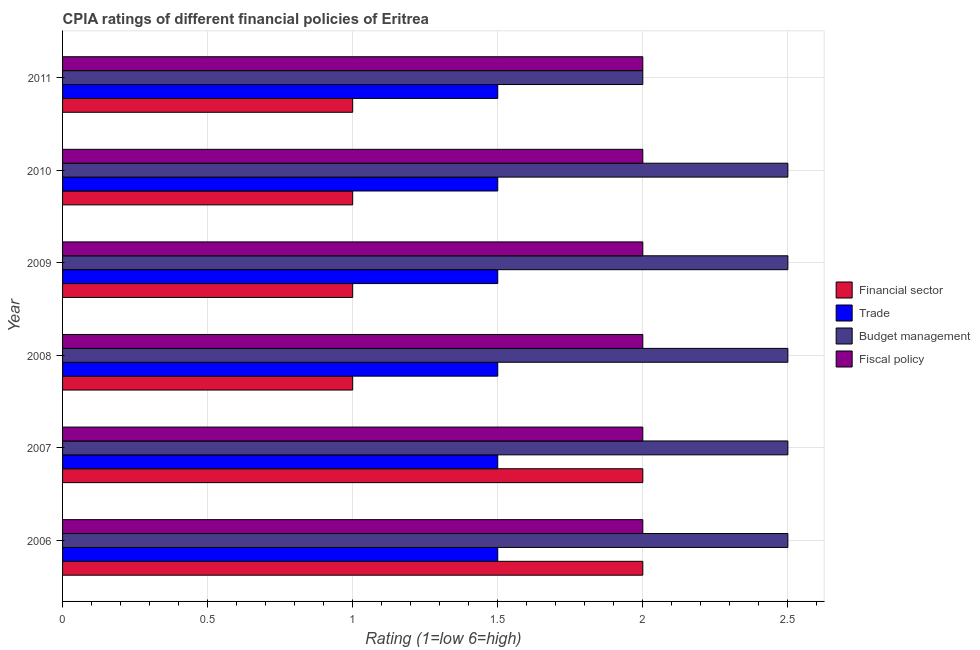How many different coloured bars are there?
Offer a very short reply. 4. How many groups of bars are there?
Keep it short and to the point. 6. Are the number of bars on each tick of the Y-axis equal?
Your response must be concise. Yes. In how many cases, is the number of bars for a given year not equal to the number of legend labels?
Ensure brevity in your answer.  0. What is the cpia rating of financial sector in 2008?
Your answer should be compact. 1. Across all years, what is the maximum cpia rating of financial sector?
Offer a terse response. 2. Across all years, what is the minimum cpia rating of trade?
Your answer should be compact. 1.5. What is the average cpia rating of budget management per year?
Your response must be concise. 2.42. In how many years, is the cpia rating of financial sector greater than 0.4 ?
Provide a succinct answer. 6. What is the ratio of the cpia rating of financial sector in 2007 to that in 2008?
Provide a short and direct response. 2. Is the cpia rating of financial sector in 2007 less than that in 2011?
Keep it short and to the point. No. Is the difference between the cpia rating of fiscal policy in 2007 and 2008 greater than the difference between the cpia rating of trade in 2007 and 2008?
Keep it short and to the point. No. What is the difference between the highest and the second highest cpia rating of financial sector?
Your answer should be compact. 0. What is the difference between the highest and the lowest cpia rating of budget management?
Your answer should be compact. 0.5. Is it the case that in every year, the sum of the cpia rating of trade and cpia rating of budget management is greater than the sum of cpia rating of financial sector and cpia rating of fiscal policy?
Give a very brief answer. Yes. What does the 4th bar from the top in 2007 represents?
Provide a succinct answer. Financial sector. What does the 3rd bar from the bottom in 2009 represents?
Give a very brief answer. Budget management. Is it the case that in every year, the sum of the cpia rating of financial sector and cpia rating of trade is greater than the cpia rating of budget management?
Your answer should be compact. No. How many bars are there?
Provide a succinct answer. 24. Are all the bars in the graph horizontal?
Offer a terse response. Yes. What is the difference between two consecutive major ticks on the X-axis?
Provide a succinct answer. 0.5. Are the values on the major ticks of X-axis written in scientific E-notation?
Give a very brief answer. No. Does the graph contain any zero values?
Your answer should be compact. No. Does the graph contain grids?
Offer a very short reply. Yes. Where does the legend appear in the graph?
Make the answer very short. Center right. How many legend labels are there?
Make the answer very short. 4. What is the title of the graph?
Provide a short and direct response. CPIA ratings of different financial policies of Eritrea. Does "Social equity" appear as one of the legend labels in the graph?
Give a very brief answer. No. What is the label or title of the X-axis?
Keep it short and to the point. Rating (1=low 6=high). What is the label or title of the Y-axis?
Offer a very short reply. Year. What is the Rating (1=low 6=high) of Financial sector in 2007?
Offer a terse response. 2. What is the Rating (1=low 6=high) in Budget management in 2007?
Offer a terse response. 2.5. What is the Rating (1=low 6=high) in Financial sector in 2008?
Ensure brevity in your answer.  1. What is the Rating (1=low 6=high) in Trade in 2009?
Make the answer very short. 1.5. What is the Rating (1=low 6=high) of Budget management in 2009?
Provide a succinct answer. 2.5. What is the Rating (1=low 6=high) in Trade in 2010?
Keep it short and to the point. 1.5. What is the Rating (1=low 6=high) in Fiscal policy in 2010?
Offer a terse response. 2. What is the Rating (1=low 6=high) in Financial sector in 2011?
Your answer should be very brief. 1. What is the Rating (1=low 6=high) of Trade in 2011?
Give a very brief answer. 1.5. Across all years, what is the maximum Rating (1=low 6=high) in Trade?
Give a very brief answer. 1.5. Across all years, what is the maximum Rating (1=low 6=high) in Fiscal policy?
Make the answer very short. 2. Across all years, what is the minimum Rating (1=low 6=high) in Trade?
Offer a terse response. 1.5. Across all years, what is the minimum Rating (1=low 6=high) of Budget management?
Offer a terse response. 2. What is the total Rating (1=low 6=high) of Financial sector in the graph?
Your answer should be very brief. 8. What is the total Rating (1=low 6=high) of Trade in the graph?
Offer a very short reply. 9. What is the total Rating (1=low 6=high) of Budget management in the graph?
Your response must be concise. 14.5. What is the total Rating (1=low 6=high) of Fiscal policy in the graph?
Keep it short and to the point. 12. What is the difference between the Rating (1=low 6=high) in Trade in 2006 and that in 2007?
Keep it short and to the point. 0. What is the difference between the Rating (1=low 6=high) of Budget management in 2006 and that in 2007?
Give a very brief answer. 0. What is the difference between the Rating (1=low 6=high) of Fiscal policy in 2006 and that in 2007?
Your answer should be compact. 0. What is the difference between the Rating (1=low 6=high) of Financial sector in 2006 and that in 2008?
Make the answer very short. 1. What is the difference between the Rating (1=low 6=high) in Trade in 2006 and that in 2008?
Make the answer very short. 0. What is the difference between the Rating (1=low 6=high) in Fiscal policy in 2006 and that in 2008?
Keep it short and to the point. 0. What is the difference between the Rating (1=low 6=high) in Trade in 2006 and that in 2010?
Offer a very short reply. 0. What is the difference between the Rating (1=low 6=high) of Budget management in 2006 and that in 2010?
Offer a very short reply. 0. What is the difference between the Rating (1=low 6=high) of Budget management in 2006 and that in 2011?
Provide a short and direct response. 0.5. What is the difference between the Rating (1=low 6=high) in Trade in 2007 and that in 2008?
Provide a short and direct response. 0. What is the difference between the Rating (1=low 6=high) in Budget management in 2007 and that in 2008?
Keep it short and to the point. 0. What is the difference between the Rating (1=low 6=high) in Fiscal policy in 2007 and that in 2008?
Offer a very short reply. 0. What is the difference between the Rating (1=low 6=high) in Trade in 2007 and that in 2009?
Make the answer very short. 0. What is the difference between the Rating (1=low 6=high) of Fiscal policy in 2007 and that in 2009?
Offer a terse response. 0. What is the difference between the Rating (1=low 6=high) of Financial sector in 2007 and that in 2010?
Your response must be concise. 1. What is the difference between the Rating (1=low 6=high) of Financial sector in 2007 and that in 2011?
Your answer should be compact. 1. What is the difference between the Rating (1=low 6=high) of Trade in 2007 and that in 2011?
Offer a terse response. 0. What is the difference between the Rating (1=low 6=high) of Budget management in 2007 and that in 2011?
Offer a terse response. 0.5. What is the difference between the Rating (1=low 6=high) in Budget management in 2008 and that in 2009?
Provide a succinct answer. 0. What is the difference between the Rating (1=low 6=high) of Fiscal policy in 2008 and that in 2009?
Your answer should be very brief. 0. What is the difference between the Rating (1=low 6=high) in Financial sector in 2008 and that in 2010?
Provide a short and direct response. 0. What is the difference between the Rating (1=low 6=high) of Fiscal policy in 2008 and that in 2011?
Make the answer very short. 0. What is the difference between the Rating (1=low 6=high) of Financial sector in 2009 and that in 2010?
Make the answer very short. 0. What is the difference between the Rating (1=low 6=high) in Trade in 2009 and that in 2010?
Offer a terse response. 0. What is the difference between the Rating (1=low 6=high) in Budget management in 2009 and that in 2010?
Make the answer very short. 0. What is the difference between the Rating (1=low 6=high) in Fiscal policy in 2009 and that in 2010?
Ensure brevity in your answer.  0. What is the difference between the Rating (1=low 6=high) in Trade in 2009 and that in 2011?
Offer a terse response. 0. What is the difference between the Rating (1=low 6=high) of Budget management in 2010 and that in 2011?
Your response must be concise. 0.5. What is the difference between the Rating (1=low 6=high) of Budget management in 2006 and the Rating (1=low 6=high) of Fiscal policy in 2007?
Ensure brevity in your answer.  0.5. What is the difference between the Rating (1=low 6=high) in Financial sector in 2006 and the Rating (1=low 6=high) in Budget management in 2008?
Your answer should be compact. -0.5. What is the difference between the Rating (1=low 6=high) in Financial sector in 2006 and the Rating (1=low 6=high) in Fiscal policy in 2008?
Give a very brief answer. 0. What is the difference between the Rating (1=low 6=high) in Trade in 2006 and the Rating (1=low 6=high) in Budget management in 2008?
Offer a very short reply. -1. What is the difference between the Rating (1=low 6=high) of Budget management in 2006 and the Rating (1=low 6=high) of Fiscal policy in 2008?
Your answer should be very brief. 0.5. What is the difference between the Rating (1=low 6=high) in Financial sector in 2006 and the Rating (1=low 6=high) in Trade in 2009?
Provide a short and direct response. 0.5. What is the difference between the Rating (1=low 6=high) in Financial sector in 2006 and the Rating (1=low 6=high) in Fiscal policy in 2009?
Keep it short and to the point. 0. What is the difference between the Rating (1=low 6=high) in Trade in 2006 and the Rating (1=low 6=high) in Fiscal policy in 2009?
Make the answer very short. -0.5. What is the difference between the Rating (1=low 6=high) in Budget management in 2006 and the Rating (1=low 6=high) in Fiscal policy in 2009?
Provide a short and direct response. 0.5. What is the difference between the Rating (1=low 6=high) of Financial sector in 2006 and the Rating (1=low 6=high) of Budget management in 2010?
Your answer should be compact. -0.5. What is the difference between the Rating (1=low 6=high) in Financial sector in 2006 and the Rating (1=low 6=high) in Fiscal policy in 2010?
Keep it short and to the point. 0. What is the difference between the Rating (1=low 6=high) in Trade in 2006 and the Rating (1=low 6=high) in Budget management in 2010?
Ensure brevity in your answer.  -1. What is the difference between the Rating (1=low 6=high) of Trade in 2006 and the Rating (1=low 6=high) of Fiscal policy in 2010?
Keep it short and to the point. -0.5. What is the difference between the Rating (1=low 6=high) of Financial sector in 2006 and the Rating (1=low 6=high) of Trade in 2011?
Offer a terse response. 0.5. What is the difference between the Rating (1=low 6=high) of Financial sector in 2006 and the Rating (1=low 6=high) of Budget management in 2011?
Make the answer very short. 0. What is the difference between the Rating (1=low 6=high) in Trade in 2006 and the Rating (1=low 6=high) in Fiscal policy in 2011?
Your response must be concise. -0.5. What is the difference between the Rating (1=low 6=high) in Financial sector in 2007 and the Rating (1=low 6=high) in Trade in 2008?
Your response must be concise. 0.5. What is the difference between the Rating (1=low 6=high) of Financial sector in 2007 and the Rating (1=low 6=high) of Fiscal policy in 2008?
Your answer should be compact. 0. What is the difference between the Rating (1=low 6=high) of Financial sector in 2007 and the Rating (1=low 6=high) of Trade in 2009?
Provide a succinct answer. 0.5. What is the difference between the Rating (1=low 6=high) in Budget management in 2007 and the Rating (1=low 6=high) in Fiscal policy in 2009?
Offer a very short reply. 0.5. What is the difference between the Rating (1=low 6=high) in Financial sector in 2007 and the Rating (1=low 6=high) in Trade in 2010?
Offer a terse response. 0.5. What is the difference between the Rating (1=low 6=high) in Financial sector in 2007 and the Rating (1=low 6=high) in Fiscal policy in 2010?
Keep it short and to the point. 0. What is the difference between the Rating (1=low 6=high) in Trade in 2007 and the Rating (1=low 6=high) in Budget management in 2010?
Make the answer very short. -1. What is the difference between the Rating (1=low 6=high) in Trade in 2007 and the Rating (1=low 6=high) in Fiscal policy in 2010?
Offer a very short reply. -0.5. What is the difference between the Rating (1=low 6=high) in Financial sector in 2007 and the Rating (1=low 6=high) in Budget management in 2011?
Your response must be concise. 0. What is the difference between the Rating (1=low 6=high) in Financial sector in 2007 and the Rating (1=low 6=high) in Fiscal policy in 2011?
Make the answer very short. 0. What is the difference between the Rating (1=low 6=high) in Budget management in 2007 and the Rating (1=low 6=high) in Fiscal policy in 2011?
Your answer should be compact. 0.5. What is the difference between the Rating (1=low 6=high) of Financial sector in 2008 and the Rating (1=low 6=high) of Budget management in 2009?
Your answer should be compact. -1.5. What is the difference between the Rating (1=low 6=high) in Budget management in 2008 and the Rating (1=low 6=high) in Fiscal policy in 2009?
Your answer should be very brief. 0.5. What is the difference between the Rating (1=low 6=high) in Financial sector in 2008 and the Rating (1=low 6=high) in Budget management in 2010?
Provide a short and direct response. -1.5. What is the difference between the Rating (1=low 6=high) of Trade in 2008 and the Rating (1=low 6=high) of Fiscal policy in 2010?
Your answer should be very brief. -0.5. What is the difference between the Rating (1=low 6=high) of Budget management in 2008 and the Rating (1=low 6=high) of Fiscal policy in 2010?
Provide a short and direct response. 0.5. What is the difference between the Rating (1=low 6=high) of Financial sector in 2008 and the Rating (1=low 6=high) of Trade in 2011?
Provide a short and direct response. -0.5. What is the difference between the Rating (1=low 6=high) of Trade in 2008 and the Rating (1=low 6=high) of Budget management in 2011?
Your answer should be compact. -0.5. What is the difference between the Rating (1=low 6=high) of Trade in 2008 and the Rating (1=low 6=high) of Fiscal policy in 2011?
Your response must be concise. -0.5. What is the difference between the Rating (1=low 6=high) of Financial sector in 2009 and the Rating (1=low 6=high) of Budget management in 2010?
Offer a very short reply. -1.5. What is the difference between the Rating (1=low 6=high) of Financial sector in 2009 and the Rating (1=low 6=high) of Fiscal policy in 2010?
Offer a terse response. -1. What is the difference between the Rating (1=low 6=high) of Trade in 2009 and the Rating (1=low 6=high) of Budget management in 2010?
Give a very brief answer. -1. What is the difference between the Rating (1=low 6=high) in Trade in 2009 and the Rating (1=low 6=high) in Fiscal policy in 2010?
Provide a short and direct response. -0.5. What is the difference between the Rating (1=low 6=high) in Financial sector in 2009 and the Rating (1=low 6=high) in Budget management in 2011?
Make the answer very short. -1. What is the difference between the Rating (1=low 6=high) in Trade in 2009 and the Rating (1=low 6=high) in Budget management in 2011?
Offer a terse response. -0.5. What is the difference between the Rating (1=low 6=high) of Trade in 2009 and the Rating (1=low 6=high) of Fiscal policy in 2011?
Offer a terse response. -0.5. What is the difference between the Rating (1=low 6=high) in Trade in 2010 and the Rating (1=low 6=high) in Budget management in 2011?
Your answer should be compact. -0.5. What is the difference between the Rating (1=low 6=high) of Trade in 2010 and the Rating (1=low 6=high) of Fiscal policy in 2011?
Give a very brief answer. -0.5. What is the average Rating (1=low 6=high) in Financial sector per year?
Provide a succinct answer. 1.33. What is the average Rating (1=low 6=high) in Trade per year?
Provide a short and direct response. 1.5. What is the average Rating (1=low 6=high) of Budget management per year?
Your answer should be compact. 2.42. In the year 2006, what is the difference between the Rating (1=low 6=high) of Trade and Rating (1=low 6=high) of Fiscal policy?
Make the answer very short. -0.5. In the year 2006, what is the difference between the Rating (1=low 6=high) in Budget management and Rating (1=low 6=high) in Fiscal policy?
Offer a very short reply. 0.5. In the year 2007, what is the difference between the Rating (1=low 6=high) in Financial sector and Rating (1=low 6=high) in Fiscal policy?
Give a very brief answer. 0. In the year 2007, what is the difference between the Rating (1=low 6=high) in Trade and Rating (1=low 6=high) in Budget management?
Your answer should be very brief. -1. In the year 2007, what is the difference between the Rating (1=low 6=high) of Trade and Rating (1=low 6=high) of Fiscal policy?
Your answer should be very brief. -0.5. In the year 2008, what is the difference between the Rating (1=low 6=high) of Financial sector and Rating (1=low 6=high) of Budget management?
Your answer should be compact. -1.5. In the year 2008, what is the difference between the Rating (1=low 6=high) in Financial sector and Rating (1=low 6=high) in Fiscal policy?
Ensure brevity in your answer.  -1. In the year 2008, what is the difference between the Rating (1=low 6=high) of Trade and Rating (1=low 6=high) of Fiscal policy?
Your answer should be very brief. -0.5. In the year 2008, what is the difference between the Rating (1=low 6=high) of Budget management and Rating (1=low 6=high) of Fiscal policy?
Offer a very short reply. 0.5. In the year 2009, what is the difference between the Rating (1=low 6=high) of Financial sector and Rating (1=low 6=high) of Fiscal policy?
Keep it short and to the point. -1. In the year 2009, what is the difference between the Rating (1=low 6=high) in Trade and Rating (1=low 6=high) in Budget management?
Keep it short and to the point. -1. In the year 2009, what is the difference between the Rating (1=low 6=high) of Trade and Rating (1=low 6=high) of Fiscal policy?
Make the answer very short. -0.5. In the year 2010, what is the difference between the Rating (1=low 6=high) in Financial sector and Rating (1=low 6=high) in Trade?
Make the answer very short. -0.5. In the year 2010, what is the difference between the Rating (1=low 6=high) of Financial sector and Rating (1=low 6=high) of Budget management?
Your answer should be very brief. -1.5. In the year 2010, what is the difference between the Rating (1=low 6=high) of Financial sector and Rating (1=low 6=high) of Fiscal policy?
Give a very brief answer. -1. In the year 2011, what is the difference between the Rating (1=low 6=high) of Trade and Rating (1=low 6=high) of Budget management?
Offer a very short reply. -0.5. In the year 2011, what is the difference between the Rating (1=low 6=high) of Budget management and Rating (1=low 6=high) of Fiscal policy?
Your response must be concise. 0. What is the ratio of the Rating (1=low 6=high) in Financial sector in 2006 to that in 2007?
Your response must be concise. 1. What is the ratio of the Rating (1=low 6=high) in Trade in 2006 to that in 2007?
Offer a terse response. 1. What is the ratio of the Rating (1=low 6=high) in Budget management in 2006 to that in 2007?
Give a very brief answer. 1. What is the ratio of the Rating (1=low 6=high) in Fiscal policy in 2006 to that in 2007?
Provide a short and direct response. 1. What is the ratio of the Rating (1=low 6=high) of Financial sector in 2006 to that in 2008?
Your answer should be very brief. 2. What is the ratio of the Rating (1=low 6=high) in Budget management in 2006 to that in 2008?
Make the answer very short. 1. What is the ratio of the Rating (1=low 6=high) of Fiscal policy in 2006 to that in 2008?
Your answer should be compact. 1. What is the ratio of the Rating (1=low 6=high) in Financial sector in 2006 to that in 2009?
Provide a short and direct response. 2. What is the ratio of the Rating (1=low 6=high) of Trade in 2006 to that in 2009?
Offer a terse response. 1. What is the ratio of the Rating (1=low 6=high) in Budget management in 2006 to that in 2009?
Make the answer very short. 1. What is the ratio of the Rating (1=low 6=high) of Budget management in 2006 to that in 2010?
Your response must be concise. 1. What is the ratio of the Rating (1=low 6=high) in Trade in 2006 to that in 2011?
Offer a terse response. 1. What is the ratio of the Rating (1=low 6=high) in Budget management in 2006 to that in 2011?
Keep it short and to the point. 1.25. What is the ratio of the Rating (1=low 6=high) in Fiscal policy in 2006 to that in 2011?
Your answer should be very brief. 1. What is the ratio of the Rating (1=low 6=high) of Financial sector in 2007 to that in 2008?
Ensure brevity in your answer.  2. What is the ratio of the Rating (1=low 6=high) in Trade in 2007 to that in 2008?
Your response must be concise. 1. What is the ratio of the Rating (1=low 6=high) of Budget management in 2007 to that in 2008?
Your answer should be compact. 1. What is the ratio of the Rating (1=low 6=high) of Fiscal policy in 2007 to that in 2008?
Provide a short and direct response. 1. What is the ratio of the Rating (1=low 6=high) of Financial sector in 2007 to that in 2009?
Your response must be concise. 2. What is the ratio of the Rating (1=low 6=high) of Trade in 2007 to that in 2009?
Provide a succinct answer. 1. What is the ratio of the Rating (1=low 6=high) of Trade in 2007 to that in 2011?
Ensure brevity in your answer.  1. What is the ratio of the Rating (1=low 6=high) of Budget management in 2007 to that in 2011?
Give a very brief answer. 1.25. What is the ratio of the Rating (1=low 6=high) of Budget management in 2008 to that in 2009?
Keep it short and to the point. 1. What is the ratio of the Rating (1=low 6=high) of Fiscal policy in 2008 to that in 2009?
Your response must be concise. 1. What is the ratio of the Rating (1=low 6=high) of Financial sector in 2008 to that in 2010?
Your answer should be compact. 1. What is the ratio of the Rating (1=low 6=high) in Trade in 2008 to that in 2010?
Offer a terse response. 1. What is the ratio of the Rating (1=low 6=high) of Fiscal policy in 2008 to that in 2010?
Your answer should be very brief. 1. What is the ratio of the Rating (1=low 6=high) of Financial sector in 2008 to that in 2011?
Make the answer very short. 1. What is the ratio of the Rating (1=low 6=high) in Budget management in 2008 to that in 2011?
Provide a succinct answer. 1.25. What is the ratio of the Rating (1=low 6=high) of Fiscal policy in 2008 to that in 2011?
Provide a succinct answer. 1. What is the ratio of the Rating (1=low 6=high) of Trade in 2009 to that in 2010?
Offer a terse response. 1. What is the ratio of the Rating (1=low 6=high) of Budget management in 2009 to that in 2010?
Provide a succinct answer. 1. What is the ratio of the Rating (1=low 6=high) in Financial sector in 2009 to that in 2011?
Ensure brevity in your answer.  1. What is the ratio of the Rating (1=low 6=high) in Trade in 2009 to that in 2011?
Make the answer very short. 1. What is the ratio of the Rating (1=low 6=high) in Budget management in 2009 to that in 2011?
Provide a short and direct response. 1.25. What is the ratio of the Rating (1=low 6=high) of Fiscal policy in 2010 to that in 2011?
Give a very brief answer. 1. What is the difference between the highest and the second highest Rating (1=low 6=high) of Trade?
Make the answer very short. 0. What is the difference between the highest and the second highest Rating (1=low 6=high) of Budget management?
Offer a very short reply. 0. What is the difference between the highest and the second highest Rating (1=low 6=high) in Fiscal policy?
Offer a very short reply. 0. What is the difference between the highest and the lowest Rating (1=low 6=high) in Trade?
Offer a terse response. 0. What is the difference between the highest and the lowest Rating (1=low 6=high) in Budget management?
Your answer should be very brief. 0.5. What is the difference between the highest and the lowest Rating (1=low 6=high) of Fiscal policy?
Offer a terse response. 0. 